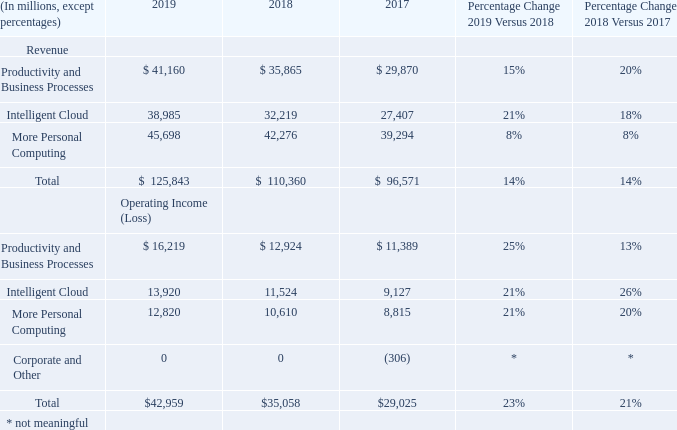SEGMENT RESULTS OF OPERATIONS
Reportable Segments
Fiscal Year 2019 Compared with Fiscal Year 2018
Productivity and Business Processes
Revenue increased $5.3 billion or 15%. • Office Commercial revenue increased $3.2 billion or 13%, driven by Office 365 Commercial, offset in part by lower revenue from products licensed on-premises, reflecting a continued shift to cloud offerings. Office 365 Commercial grew 33%, due to growth in seats and higher average revenue per user. • Office Consumer revenue increased $286 million or 7%, driven by Office 365 Consumer, due to recurring subscription revenue and transactional strength in Japan. • LinkedIn revenue increased $1.5 billion or 28%, driven by growth across each line of business. • Dynamics revenue increased 15%, driven by Dynamics 365 growth.
Operating income increased $3.3 billion or 25%, including an unfavorable foreign currency impact of 2%.

• Gross margin increased $4.1 billion or 15%, driven by growth in Office Commercial and LinkedIn. Gross margin percentage increased slightly, due to gross margin percentage improvement in LinkedIn and Office 365 Commercial, offset in part by an increased mix of cloud offerings.

• Operating expenses increased $806 million or 6%, driven by investments in LinkedIn and cloud engineering, offset in part by a decrease in marketing.
Intelligent Cloud
Revenue increased $6.8 billion or 21%.

• Server products and cloud services revenue, including GitHub, increased $6.5 billion or 25%, driven by Azure. Azure revenue growth was 72%, due to higher infrastructure-as-a-service and platform-as-a-service consumption-based and per user-based services. Server products revenue increased 6%, due to continued demand for premium versions and hybrid solutions, GitHub, and demand ahead of end-of-support for SQL Server 2008 and Windows Server 2008.

• Enterprise Services revenue increased $278 million or 5%, driven by growth in Premier Support Services and Microsoft Consulting Services.
Operating income increased $2.4 billion or 21%.

• Gross margin increased $4.8 billion or 22%, driven by growth in server products and cloud services revenue and cloud services scale and efficiencies. Gross margin percentage increased slightly, due to gross margin percentage improvement in Azure, offset in part by an increased mix of cloud offerings.

• Operating expenses increased $2.4 billion or 22%, driven by investments in cloud and AI engineering, GitHub, and commercial sales capacity.
More Personal Computing
Revenue increased $3.4 billion or 8%.

• Windows revenue increased $877 million or 4%, driven by growth in Windows Commercial and Windows OEM, offset in part by a decline in patent licensing. Windows Commercial revenue increased 14%, driven by an increased mix of multi-year agreements that carry higher in-quarter revenue recognition. Windows OEM revenue increased 4%. Windows OEM Pro revenue grew 10%, ahead of the commercial PC market, driven by healthy Windows 10 demand. Windows OEM non-Pro revenue declined 7%, below the consumer PC market, driven by continued pressure in the entry level category.

• Surface revenue increased $1.1 billion or 23%, with strong growth across commercial and consumer.

• Gaming revenue increased $1.0 billion or 10%, driven by Xbox software and services growth of 19%, primarily due to third-party title strength and subscriptions growth, offset in part by a decline in Xbox hardware of 13% primarily due to a decrease in volume of consoles sold.

• Search advertising revenue increased $616 million or 9%. Search advertising revenue, excluding traffic acquisition costs, increased 13%, driven by higher revenue per search.
Operating income increased $2.2 billion or 21%, including an unfavorable foreign currency impact of 2%.

• Gross margin increased $2.0 billion or 9%, driven by growth in Windows, Gaming, and Search. Gross margin percentage increased slightly, due to a sales mix shift to higher gross margin businesses in Windows and Gaming.

• Operating expenses decreased $172 million or 1%.
Fiscal Year 2018 Compared with Fiscal Year 2017
Productivity and Business Processes
Revenue increased $6.0 billion or 20%.

• LinkedIn revenue increased $3.0 billion to $5.3 billion. Fiscal year 2018 included a full period of results, whereas fiscal year 2017 only included results from the date of acquisition on December 8, 2016. LinkedIn revenue primarily consisted of revenue from Talent Solutions.

• Office Commercial revenue increased $2.4 billion or 11%, driven by Office 365 Commercial revenue growth, mainly due to growth in subscribers and average revenue per user, offset in part by lower revenue from products licensed on-premises, reflecting a continued shift to Office 365 Commercial.

• Office Consumer revenue increased $382 million or 11%, driven by Office 365 Consumer revenue growth, mainly due to growth in subscribers.

• Dynamics revenue increased 13%, driven by Dynamics 365 revenue growth.
Operating income increased $1.5 billion or 13%, including a favorable foreign currency impact of 2%.

• Gross margin increased $4.4 billion or 19%, driven by LinkedIn and growth in Office Commercial. Gross margin percentage decreased slightly, due to an increased mix of cloud offerings, offset in part by gross margin percentage improvement in Office 365 Commercial and LinkedIn. LinkedIn cost of revenue increased $818 million to $1.7 billion, including $888 million of amortization for acquired intangible assets.

• Operating expenses increased $2.9 billion or 25%, driven by LinkedIn expenses and investments in commercial sales capacity and cloud engineering. LinkedIn operating expenses increased $2.2 billion to $4.5 billion, including $617 million of amortization of acquired intangible assets.
Intelligent Cloud
Revenue increased $4.8 billion or 18%.

• Server products and cloud services revenue increased $4.5 billion or 21%, driven by Azure and server products licensed on-premises revenue growth. Azure revenue grew 91%, due to higher infrastructure-as-a-service and platform-as-a-service consumption-based and per user-based services. Server products licensed on-premises revenue increased 5%, mainly due to a higher mix of premium licenses for Windows Server and Microsoft SQL Server.

• Enterprise Services revenue increased $304 million or 5%, driven by higher revenue from Premier Support Services and Microsoft Consulting Services, offset in part by a decline in revenue from custom support agreements.
Operating income increased $2.4 billion or 26%.

• Gross margin increased $3.1 billion or 16%, driven by growth in server products and cloud services revenue and cloud services scale and efficiencies. Gross margin percentage decreased, due to an increased mix of cloud offerings, offset in part by gross margin percentage improvement in Azure.

• Operating expenses increased $683 million or 7%, driven by investments in commercial sales capacity and cloud engineering.
More Personal Computing
Revenue increased $3.0 billion or 8%.

• Windows revenue increased $925 million or 5%, driven by growth in Windows Commercial and Windows OEM, offset by a decline in patent licensing revenue. Windows Commercial revenue increased 12%, driven by multi-year agreement revenue growth. Windows OEM revenue increased 5%. Windows OEM Pro revenue grew 11%, ahead of a strengthening commercial PC market. Windows OEM non-Pro revenue declined 4%, below the consumer PC market, driven by continued pressure in the entry-level price category.

• Gaming revenue increased $1.3 billion or 14%, driven by Xbox software and services revenue growth of 20%, mainly from third-party title strength.

• Search advertising revenue increased $793 million or 13%. Search advertising revenue, excluding traffic acquisition costs, increased 16%, driven by growth in Bing, due to higher revenue per search and search volume.

• Surface revenue increased $625 million or 16%, driven by a higher mix of premium devices and an increase in volumes sold, due to the latest editions of Surface.

• Phone revenue decreased $525 million.
Operating income increased $1.8 billion or 20%, including a favorable foreign currency impact of 2%.

• Gross margin increased $2.2 billion or 11%, driven by growth in Windows, Surface, Search, and Gaming. Gross margin percentage increased, primarily due to gross margin percentage improvement in Surface.

• Operating expenses increased $391 million or 3%, driven by investments in Search, AI, and Gaming engineering and commercial sales capacity, offset in part by a decrease in Windows marketing expenses.
Corporate and Other

Corporate and Other includes corporate-level activity not specifically allocated to a segment, including restructuring expenses.

Fiscal Year 2019 Compared with Fiscal Year 2018

We did not incur Corporate and Other activity in fiscal years 2019 or 2018.

Fiscal Year 2018 Compared with Fiscal Year 2017

Corporate and Other operating loss decreased $306 million, due to a reduction in restructuring expenses, driven by employee severance expenses primarily related to our sales and marketing restructuring plan in fiscal year 2017.
Why did corporate and other operating loss decrease in 2018? Due to a reduction in restructuring expenses, driven by employee severance expenses primarily related to our sales and marketing restructuring plan in fiscal year 2017. Why did revenue increase on Office 365 Commercial in 2019 from 2018? Due to growth in seats and higher average revenue per user. Why did server products revenue increase 6%? Due to continued demand for premium versions and hybrid solutions, github, and demand ahead of end-of-support for sql server 2008 and windows server 2008. What was the intelligent cloud as a percentage of total revenue in 2019?
Answer scale should be: percent. 38,985/125,843
Answer: 30.98. How many revenue categories are there? Productivity and Business Processes##Intelligent Cloud##More Personal Computing
Answer: 3. What is the average operating income from 2017 to 2019?
Answer scale should be: million. (42,959+35,058+29,025)/3
Answer: 35680.67. 